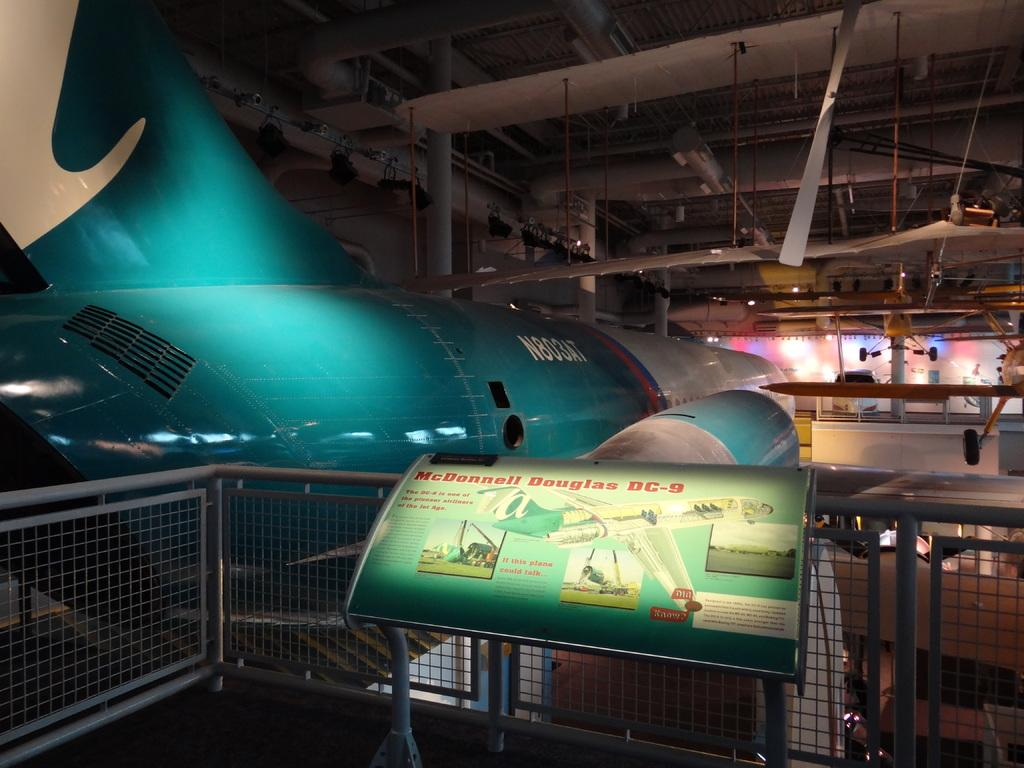Provide a one-sentence caption for the provided image. A plane, called the McDonnell Douglas DC-9, is on display in a museum. 